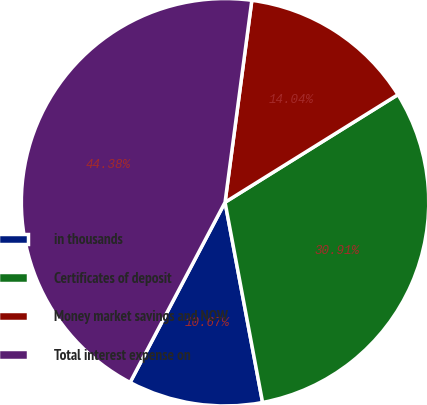<chart> <loc_0><loc_0><loc_500><loc_500><pie_chart><fcel>in thousands<fcel>Certificates of deposit<fcel>Money market savings and NOW<fcel>Total interest expense on<nl><fcel>10.67%<fcel>30.91%<fcel>14.04%<fcel>44.38%<nl></chart> 